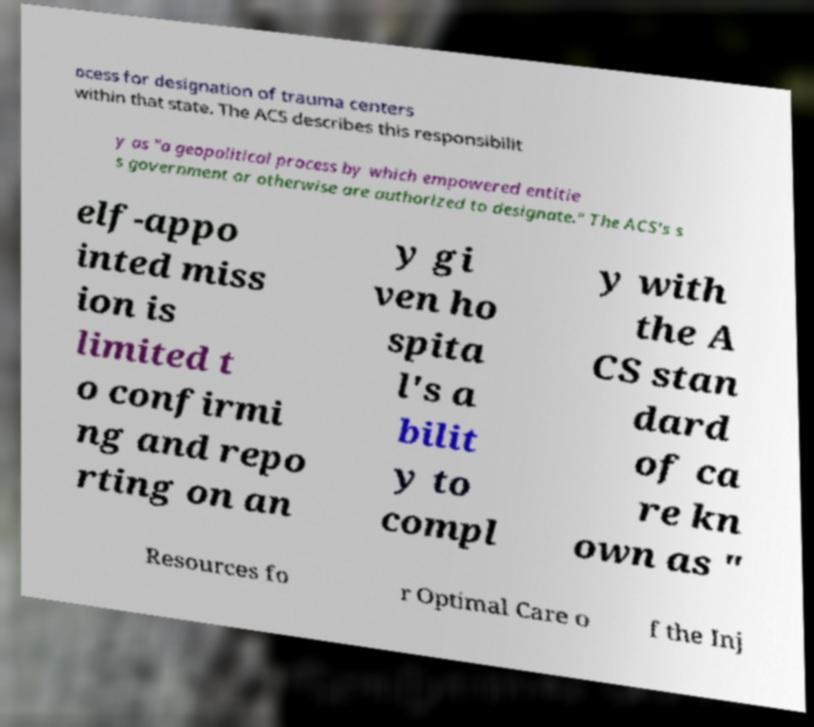There's text embedded in this image that I need extracted. Can you transcribe it verbatim? ocess for designation of trauma centers within that state. The ACS describes this responsibilit y as "a geopolitical process by which empowered entitie s government or otherwise are authorized to designate." The ACS's s elf-appo inted miss ion is limited t o confirmi ng and repo rting on an y gi ven ho spita l's a bilit y to compl y with the A CS stan dard of ca re kn own as " Resources fo r Optimal Care o f the Inj 